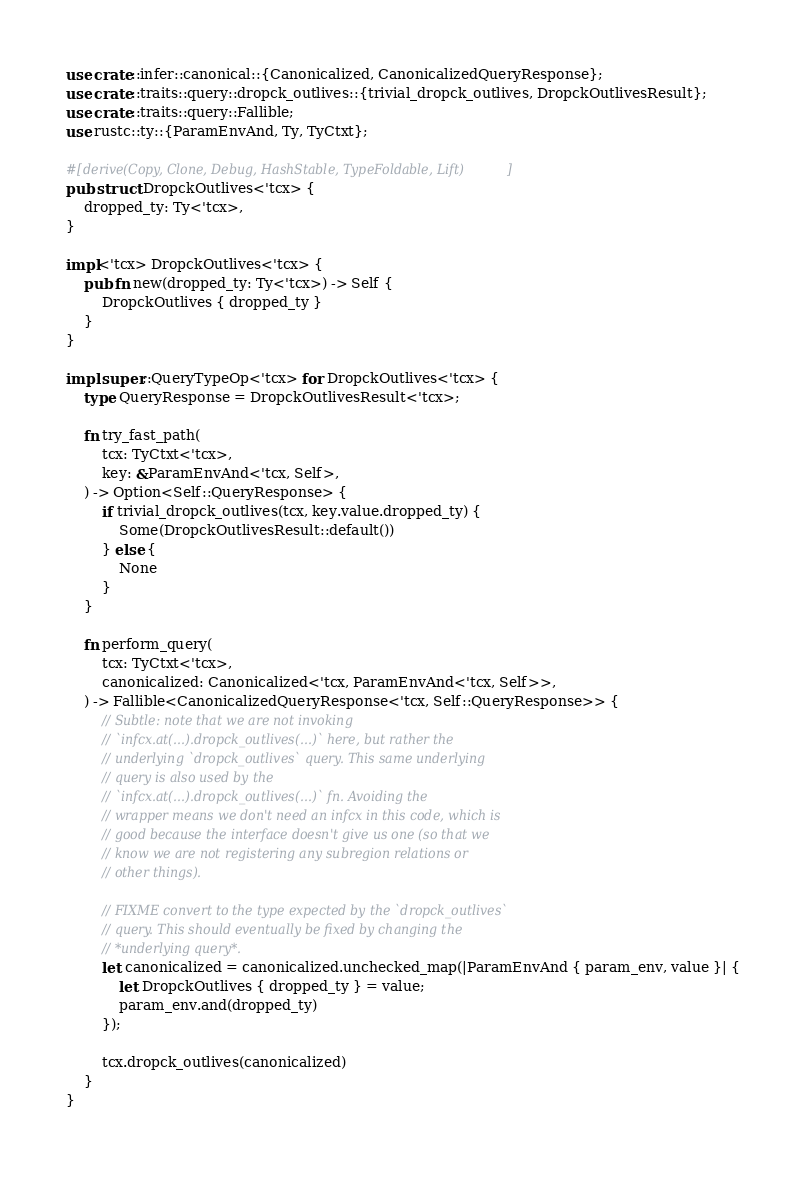<code> <loc_0><loc_0><loc_500><loc_500><_Rust_>use crate::infer::canonical::{Canonicalized, CanonicalizedQueryResponse};
use crate::traits::query::dropck_outlives::{trivial_dropck_outlives, DropckOutlivesResult};
use crate::traits::query::Fallible;
use rustc::ty::{ParamEnvAnd, Ty, TyCtxt};

#[derive(Copy, Clone, Debug, HashStable, TypeFoldable, Lift)]
pub struct DropckOutlives<'tcx> {
    dropped_ty: Ty<'tcx>,
}

impl<'tcx> DropckOutlives<'tcx> {
    pub fn new(dropped_ty: Ty<'tcx>) -> Self {
        DropckOutlives { dropped_ty }
    }
}

impl super::QueryTypeOp<'tcx> for DropckOutlives<'tcx> {
    type QueryResponse = DropckOutlivesResult<'tcx>;

    fn try_fast_path(
        tcx: TyCtxt<'tcx>,
        key: &ParamEnvAnd<'tcx, Self>,
    ) -> Option<Self::QueryResponse> {
        if trivial_dropck_outlives(tcx, key.value.dropped_ty) {
            Some(DropckOutlivesResult::default())
        } else {
            None
        }
    }

    fn perform_query(
        tcx: TyCtxt<'tcx>,
        canonicalized: Canonicalized<'tcx, ParamEnvAnd<'tcx, Self>>,
    ) -> Fallible<CanonicalizedQueryResponse<'tcx, Self::QueryResponse>> {
        // Subtle: note that we are not invoking
        // `infcx.at(...).dropck_outlives(...)` here, but rather the
        // underlying `dropck_outlives` query. This same underlying
        // query is also used by the
        // `infcx.at(...).dropck_outlives(...)` fn. Avoiding the
        // wrapper means we don't need an infcx in this code, which is
        // good because the interface doesn't give us one (so that we
        // know we are not registering any subregion relations or
        // other things).

        // FIXME convert to the type expected by the `dropck_outlives`
        // query. This should eventually be fixed by changing the
        // *underlying query*.
        let canonicalized = canonicalized.unchecked_map(|ParamEnvAnd { param_env, value }| {
            let DropckOutlives { dropped_ty } = value;
            param_env.and(dropped_ty)
        });

        tcx.dropck_outlives(canonicalized)
    }
}
</code> 